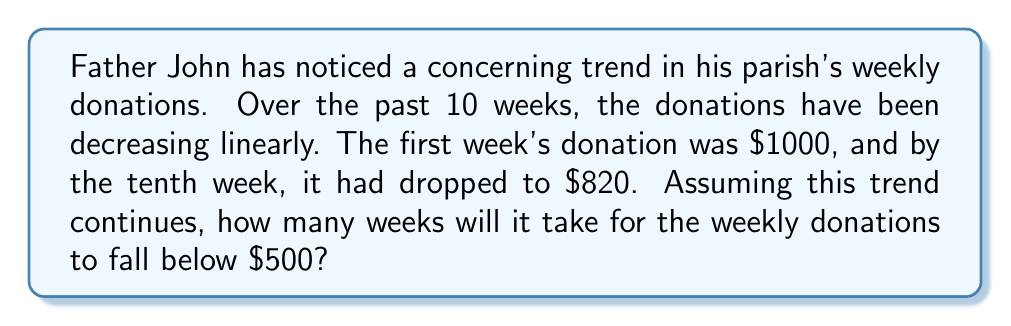Can you solve this math problem? To solve this problem, we need to follow these steps:

1. Calculate the rate of decline per week:
   Let's define a function $D(w)$ where $D$ is the donation amount and $w$ is the week number.
   
   We know two points: $(1, 1000)$ and $(10, 820)$
   
   The slope (rate of decline) can be calculated as:
   $$m = \frac{820 - 1000}{10 - 1} = -20$$

   So, the donations are decreasing by $20 per week.

2. Set up the linear equation:
   $$D(w) = -20w + b$$
   where $b$ is the y-intercept (initial donation amount)

3. Find the y-intercept:
   We can use the first week's donation to find $b$:
   $$1000 = -20(1) + b$$
   $$b = 1020$$

   So our equation is:
   $$D(w) = -20w + 1020$$

4. Solve for when $D(w) = 500$:
   $$500 = -20w + 1020$$
   $$-520 = -20w$$
   $$w = 26$$

Therefore, it will take 26 weeks for the donations to fall below $500.
Answer: 26 weeks 